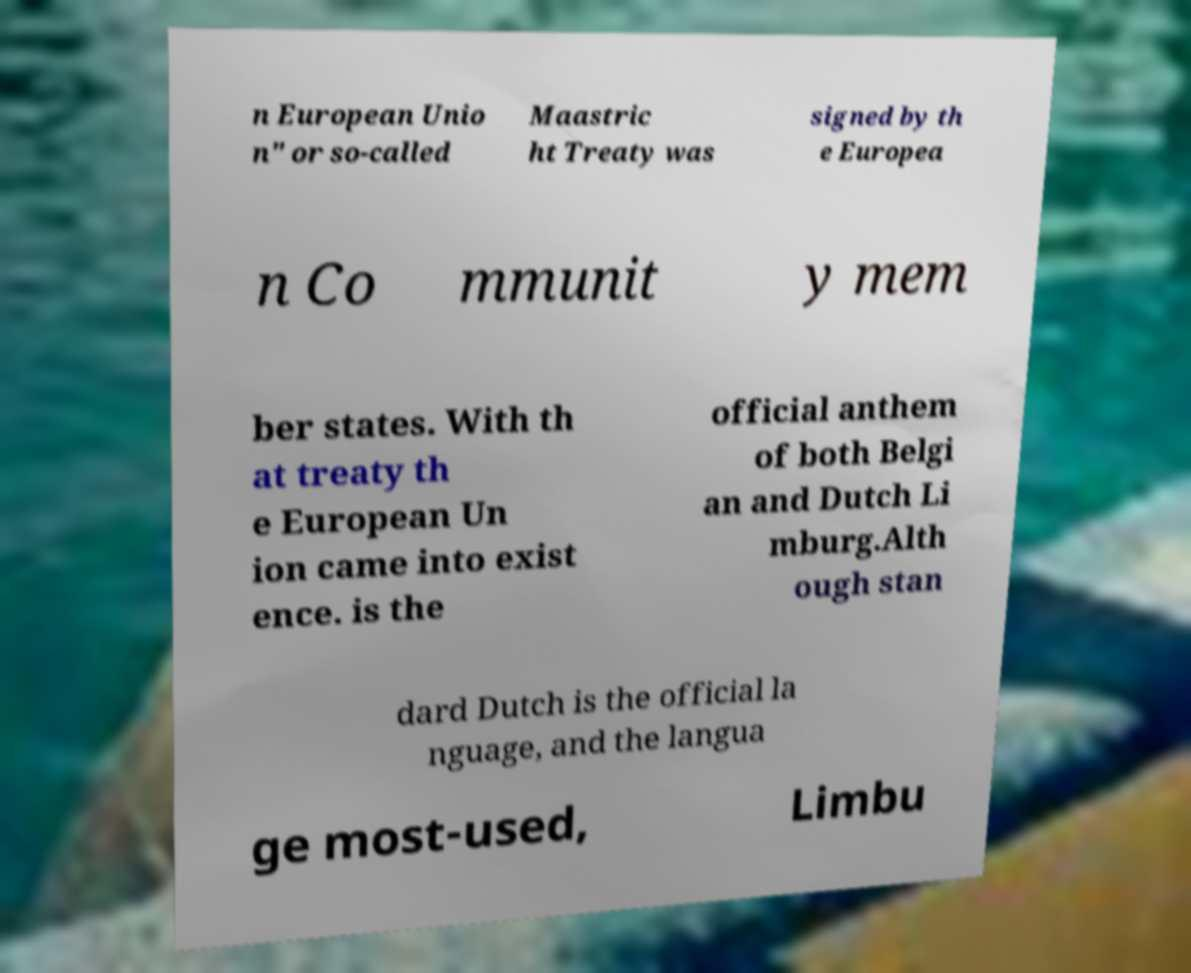Can you read and provide the text displayed in the image?This photo seems to have some interesting text. Can you extract and type it out for me? n European Unio n" or so-called Maastric ht Treaty was signed by th e Europea n Co mmunit y mem ber states. With th at treaty th e European Un ion came into exist ence. is the official anthem of both Belgi an and Dutch Li mburg.Alth ough stan dard Dutch is the official la nguage, and the langua ge most-used, Limbu 